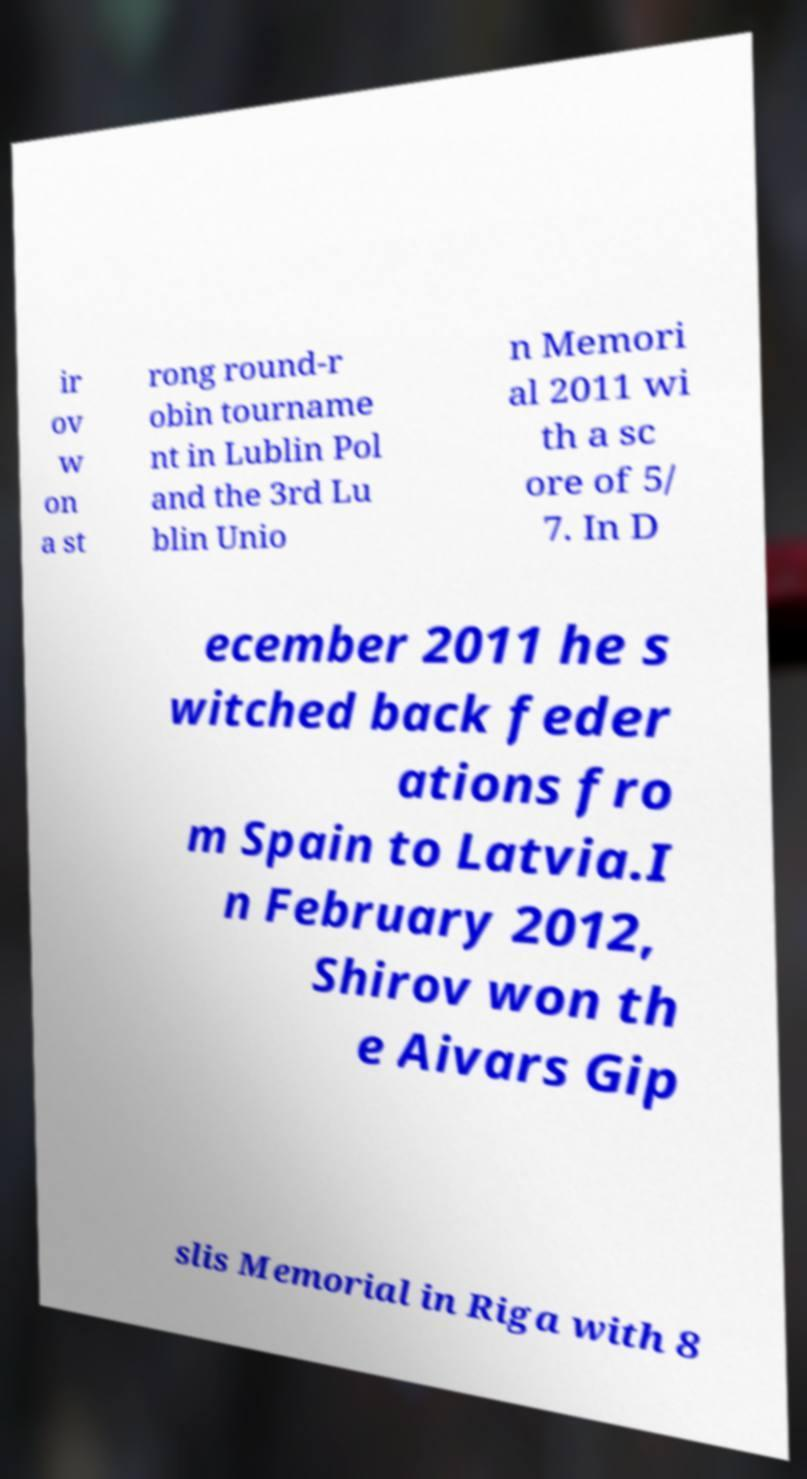There's text embedded in this image that I need extracted. Can you transcribe it verbatim? ir ov w on a st rong round-r obin tourname nt in Lublin Pol and the 3rd Lu blin Unio n Memori al 2011 wi th a sc ore of 5/ 7. In D ecember 2011 he s witched back feder ations fro m Spain to Latvia.I n February 2012, Shirov won th e Aivars Gip slis Memorial in Riga with 8 